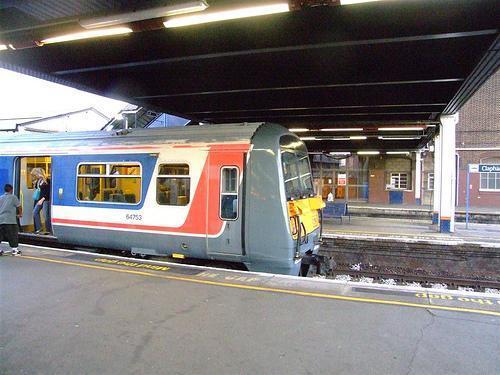How many people are near the train?
Give a very brief answer. 1. 